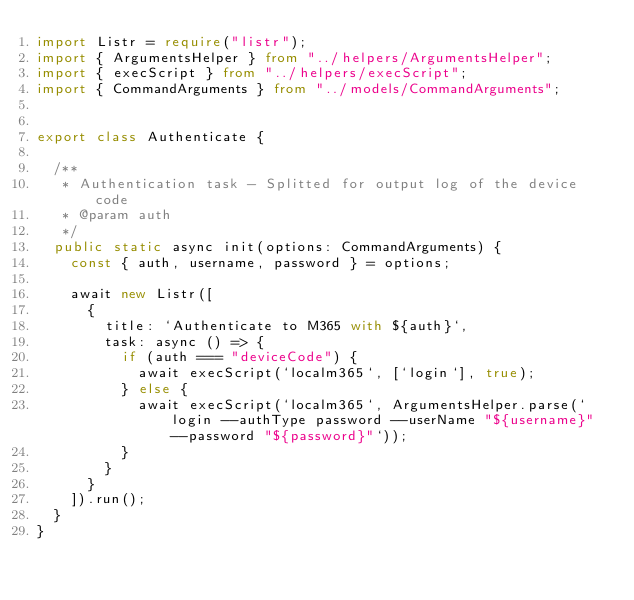Convert code to text. <code><loc_0><loc_0><loc_500><loc_500><_TypeScript_>import Listr = require("listr");
import { ArgumentsHelper } from "../helpers/ArgumentsHelper";
import { execScript } from "../helpers/execScript";
import { CommandArguments } from "../models/CommandArguments";


export class Authenticate {

  /**
   * Authentication task - Splitted for output log of the device code
   * @param auth 
   */
  public static async init(options: CommandArguments) {
    const { auth, username, password } = options;

    await new Listr([
      {
        title: `Authenticate to M365 with ${auth}`,
        task: async () => {
          if (auth === "deviceCode") {
            await execScript(`localm365`, [`login`], true);
          } else {
            await execScript(`localm365`, ArgumentsHelper.parse(`login --authType password --userName "${username}" --password "${password}"`));
          }
        }
      }
    ]).run();
  }
}</code> 